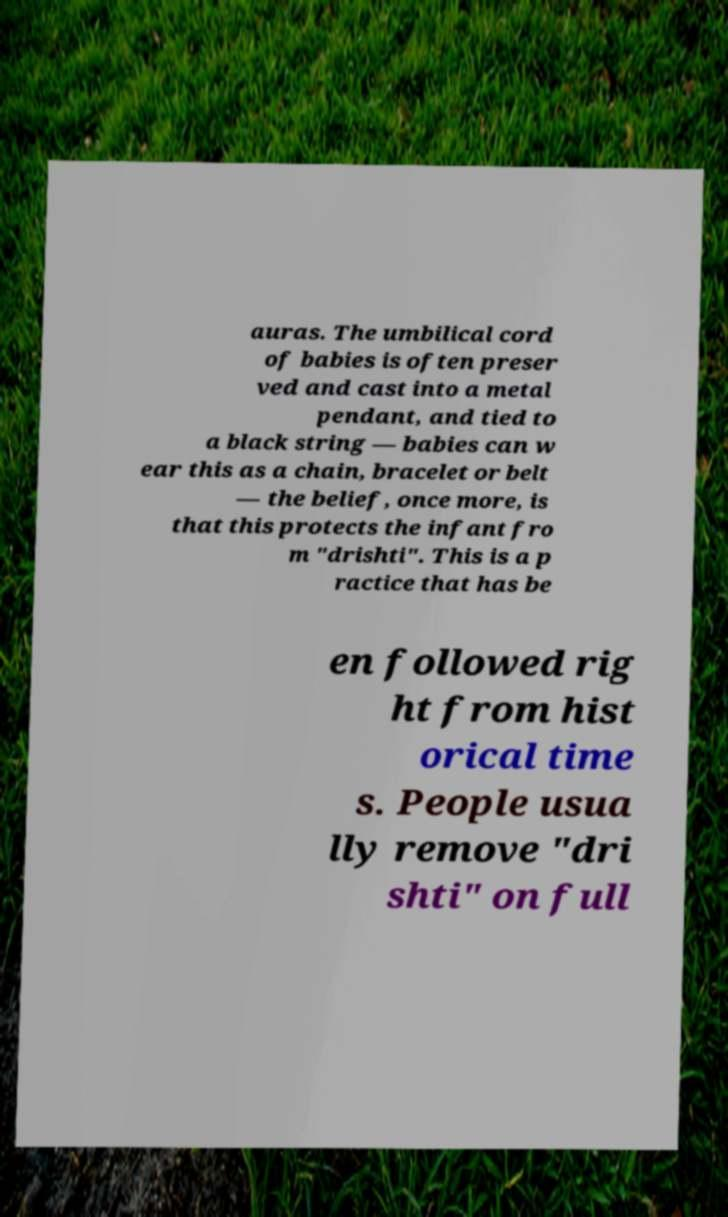There's text embedded in this image that I need extracted. Can you transcribe it verbatim? auras. The umbilical cord of babies is often preser ved and cast into a metal pendant, and tied to a black string — babies can w ear this as a chain, bracelet or belt — the belief, once more, is that this protects the infant fro m "drishti". This is a p ractice that has be en followed rig ht from hist orical time s. People usua lly remove "dri shti" on full 